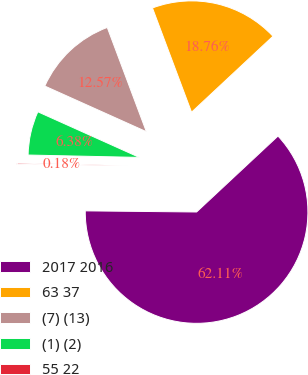Convert chart to OTSL. <chart><loc_0><loc_0><loc_500><loc_500><pie_chart><fcel>2017 2016<fcel>63 37<fcel>(7) (13)<fcel>(1) (2)<fcel>55 22<nl><fcel>62.11%<fcel>18.76%<fcel>12.57%<fcel>6.38%<fcel>0.18%<nl></chart> 